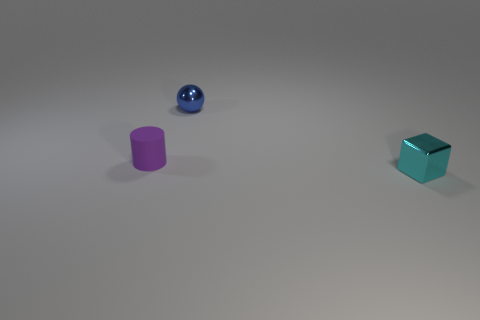What materials seem to be used in the three objects depicted, and can you infer anything about their weights relative to each other? The three objects appear to be made from different materials. The blue sphere looks glossy, possibly a light-weight plastic. The purple cylinder has a matte finish, and could also be a light plastic. The cube's reflective surface suggests a heavier metal, likely steel or aluminum. Based on their materials, the metal cube is probably the heaviest, followed by the purple cylinder, and the blue sphere being the lightest. 